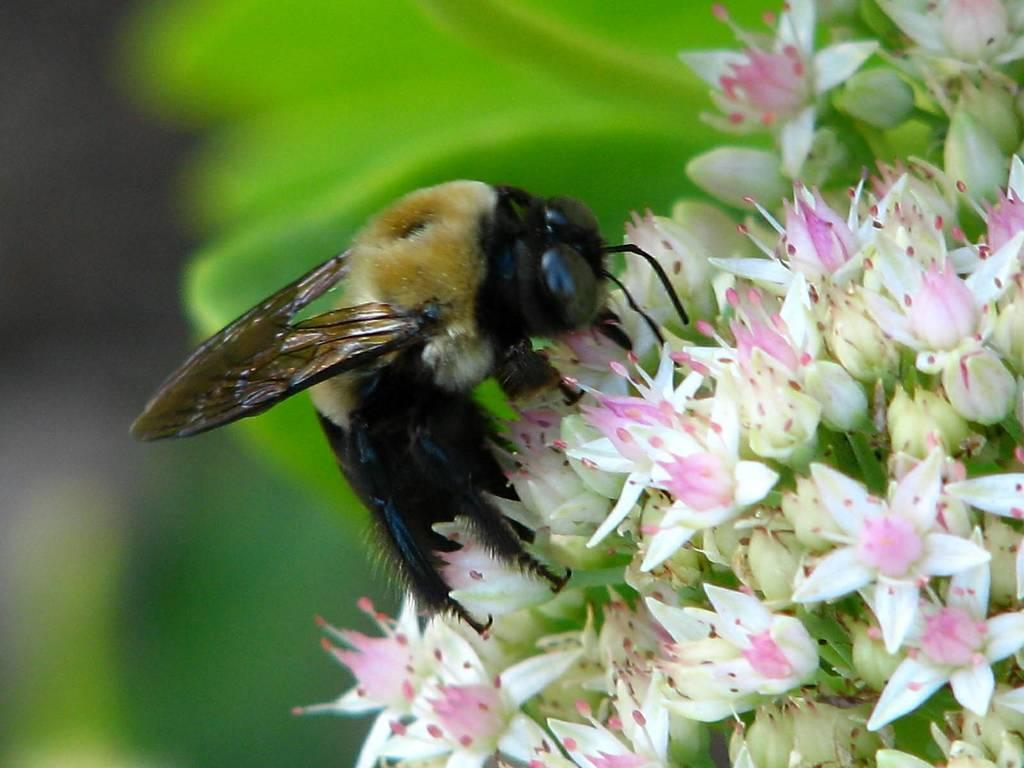What is the main subject of the picture? The main subject of the picture is an insect. Where is the insect located in the image? The insect is on flowers. Can you describe the background of the image? The background of the image is blurred. What type of school can be seen in the background of the image? There is no school present in the image; the background is blurred and does not show any buildings or structures. 